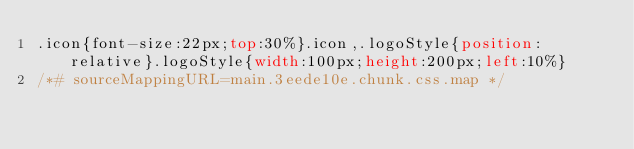<code> <loc_0><loc_0><loc_500><loc_500><_CSS_>.icon{font-size:22px;top:30%}.icon,.logoStyle{position:relative}.logoStyle{width:100px;height:200px;left:10%}
/*# sourceMappingURL=main.3eede10e.chunk.css.map */</code> 